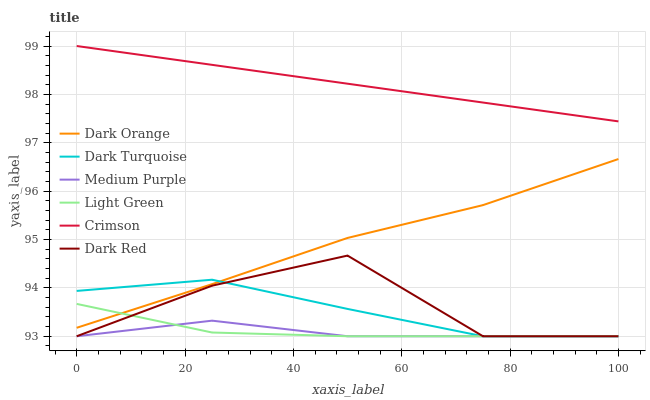Does Medium Purple have the minimum area under the curve?
Answer yes or no. Yes. Does Crimson have the maximum area under the curve?
Answer yes or no. Yes. Does Dark Red have the minimum area under the curve?
Answer yes or no. No. Does Dark Red have the maximum area under the curve?
Answer yes or no. No. Is Crimson the smoothest?
Answer yes or no. Yes. Is Dark Red the roughest?
Answer yes or no. Yes. Is Medium Purple the smoothest?
Answer yes or no. No. Is Medium Purple the roughest?
Answer yes or no. No. Does Dark Red have the lowest value?
Answer yes or no. Yes. Does Crimson have the lowest value?
Answer yes or no. No. Does Crimson have the highest value?
Answer yes or no. Yes. Does Dark Red have the highest value?
Answer yes or no. No. Is Dark Turquoise less than Crimson?
Answer yes or no. Yes. Is Dark Orange greater than Medium Purple?
Answer yes or no. Yes. Does Dark Orange intersect Light Green?
Answer yes or no. Yes. Is Dark Orange less than Light Green?
Answer yes or no. No. Is Dark Orange greater than Light Green?
Answer yes or no. No. Does Dark Turquoise intersect Crimson?
Answer yes or no. No. 